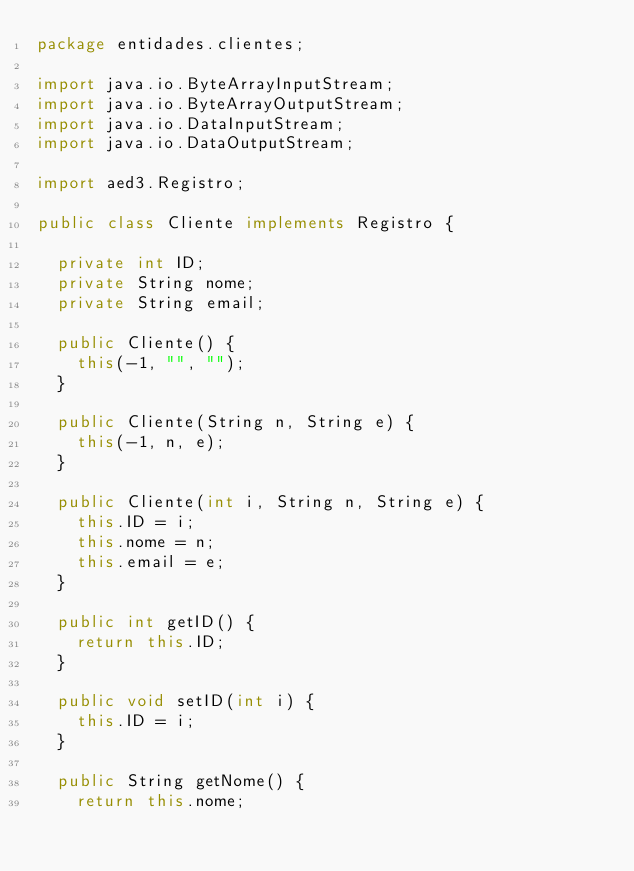Convert code to text. <code><loc_0><loc_0><loc_500><loc_500><_Java_>package entidades.clientes;

import java.io.ByteArrayInputStream;
import java.io.ByteArrayOutputStream;
import java.io.DataInputStream;
import java.io.DataOutputStream;

import aed3.Registro;

public class Cliente implements Registro {

  private int ID;
  private String nome;
  private String email;

  public Cliente() {
    this(-1, "", "");
  }

  public Cliente(String n, String e) {
    this(-1, n, e);
  }

  public Cliente(int i, String n, String e) {
    this.ID = i;
    this.nome = n;
    this.email = e;
  }

  public int getID() {
    return this.ID;
  }

  public void setID(int i) {
    this.ID = i;
  }

  public String getNome() {
    return this.nome;</code> 